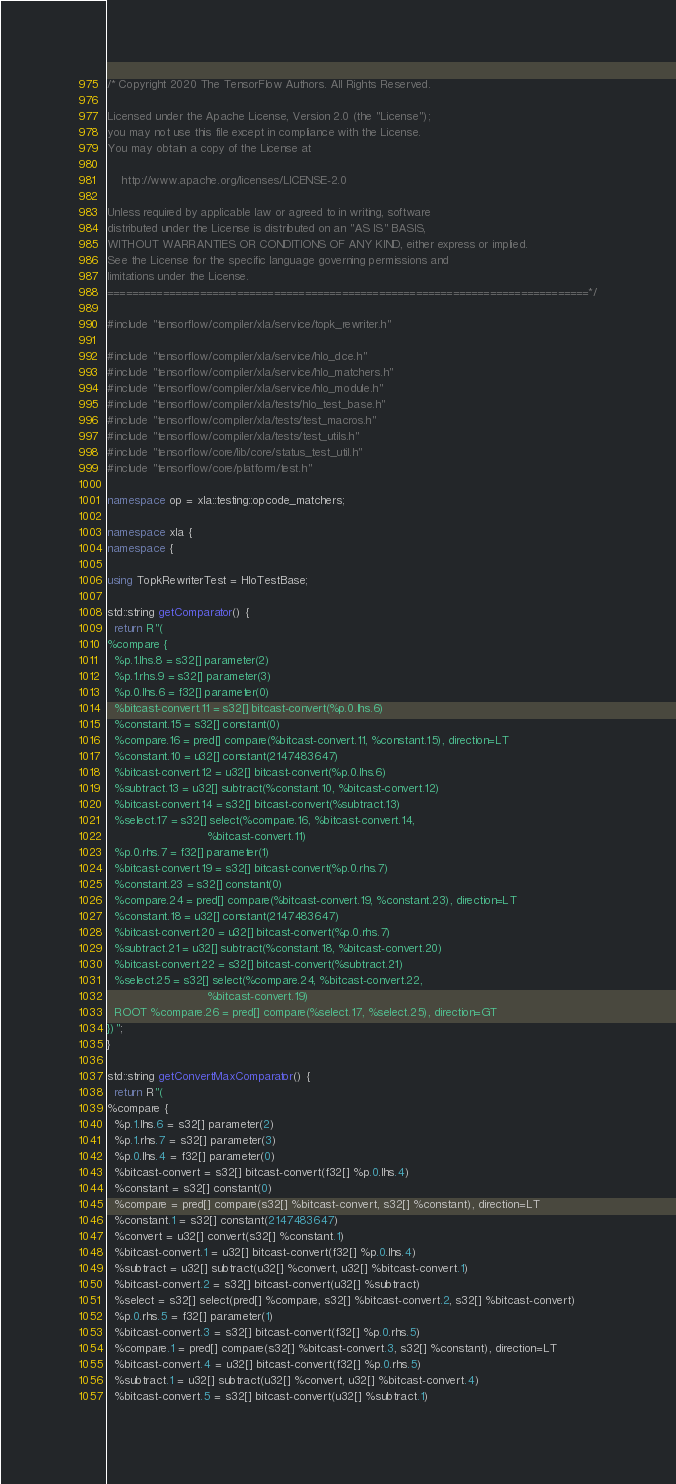Convert code to text. <code><loc_0><loc_0><loc_500><loc_500><_C++_>/* Copyright 2020 The TensorFlow Authors. All Rights Reserved.

Licensed under the Apache License, Version 2.0 (the "License");
you may not use this file except in compliance with the License.
You may obtain a copy of the License at

    http://www.apache.org/licenses/LICENSE-2.0

Unless required by applicable law or agreed to in writing, software
distributed under the License is distributed on an "AS IS" BASIS,
WITHOUT WARRANTIES OR CONDITIONS OF ANY KIND, either express or implied.
See the License for the specific language governing permissions and
limitations under the License.
==============================================================================*/

#include "tensorflow/compiler/xla/service/topk_rewriter.h"

#include "tensorflow/compiler/xla/service/hlo_dce.h"
#include "tensorflow/compiler/xla/service/hlo_matchers.h"
#include "tensorflow/compiler/xla/service/hlo_module.h"
#include "tensorflow/compiler/xla/tests/hlo_test_base.h"
#include "tensorflow/compiler/xla/tests/test_macros.h"
#include "tensorflow/compiler/xla/tests/test_utils.h"
#include "tensorflow/core/lib/core/status_test_util.h"
#include "tensorflow/core/platform/test.h"

namespace op = xla::testing::opcode_matchers;

namespace xla {
namespace {

using TopkRewriterTest = HloTestBase;

std::string getComparator() {
  return R"(
%compare {
  %p.1.lhs.8 = s32[] parameter(2)
  %p.1.rhs.9 = s32[] parameter(3)
  %p.0.lhs.6 = f32[] parameter(0)
  %bitcast-convert.11 = s32[] bitcast-convert(%p.0.lhs.6)
  %constant.15 = s32[] constant(0)
  %compare.16 = pred[] compare(%bitcast-convert.11, %constant.15), direction=LT
  %constant.10 = u32[] constant(2147483647)
  %bitcast-convert.12 = u32[] bitcast-convert(%p.0.lhs.6)
  %subtract.13 = u32[] subtract(%constant.10, %bitcast-convert.12)
  %bitcast-convert.14 = s32[] bitcast-convert(%subtract.13)
  %select.17 = s32[] select(%compare.16, %bitcast-convert.14,
                            %bitcast-convert.11)
  %p.0.rhs.7 = f32[] parameter(1)
  %bitcast-convert.19 = s32[] bitcast-convert(%p.0.rhs.7)
  %constant.23 = s32[] constant(0)
  %compare.24 = pred[] compare(%bitcast-convert.19, %constant.23), direction=LT
  %constant.18 = u32[] constant(2147483647)
  %bitcast-convert.20 = u32[] bitcast-convert(%p.0.rhs.7)
  %subtract.21 = u32[] subtract(%constant.18, %bitcast-convert.20)
  %bitcast-convert.22 = s32[] bitcast-convert(%subtract.21)
  %select.25 = s32[] select(%compare.24, %bitcast-convert.22,
                            %bitcast-convert.19)
  ROOT %compare.26 = pred[] compare(%select.17, %select.25), direction=GT
})";
}

std::string getConvertMaxComparator() {
  return R"(
%compare {
  %p.1.lhs.6 = s32[] parameter(2)
  %p.1.rhs.7 = s32[] parameter(3)
  %p.0.lhs.4 = f32[] parameter(0)
  %bitcast-convert = s32[] bitcast-convert(f32[] %p.0.lhs.4)
  %constant = s32[] constant(0)
  %compare = pred[] compare(s32[] %bitcast-convert, s32[] %constant), direction=LT
  %constant.1 = s32[] constant(2147483647)
  %convert = u32[] convert(s32[] %constant.1)
  %bitcast-convert.1 = u32[] bitcast-convert(f32[] %p.0.lhs.4)
  %subtract = u32[] subtract(u32[] %convert, u32[] %bitcast-convert.1)
  %bitcast-convert.2 = s32[] bitcast-convert(u32[] %subtract)
  %select = s32[] select(pred[] %compare, s32[] %bitcast-convert.2, s32[] %bitcast-convert)
  %p.0.rhs.5 = f32[] parameter(1)
  %bitcast-convert.3 = s32[] bitcast-convert(f32[] %p.0.rhs.5)
  %compare.1 = pred[] compare(s32[] %bitcast-convert.3, s32[] %constant), direction=LT
  %bitcast-convert.4 = u32[] bitcast-convert(f32[] %p.0.rhs.5)
  %subtract.1 = u32[] subtract(u32[] %convert, u32[] %bitcast-convert.4)
  %bitcast-convert.5 = s32[] bitcast-convert(u32[] %subtract.1)</code> 